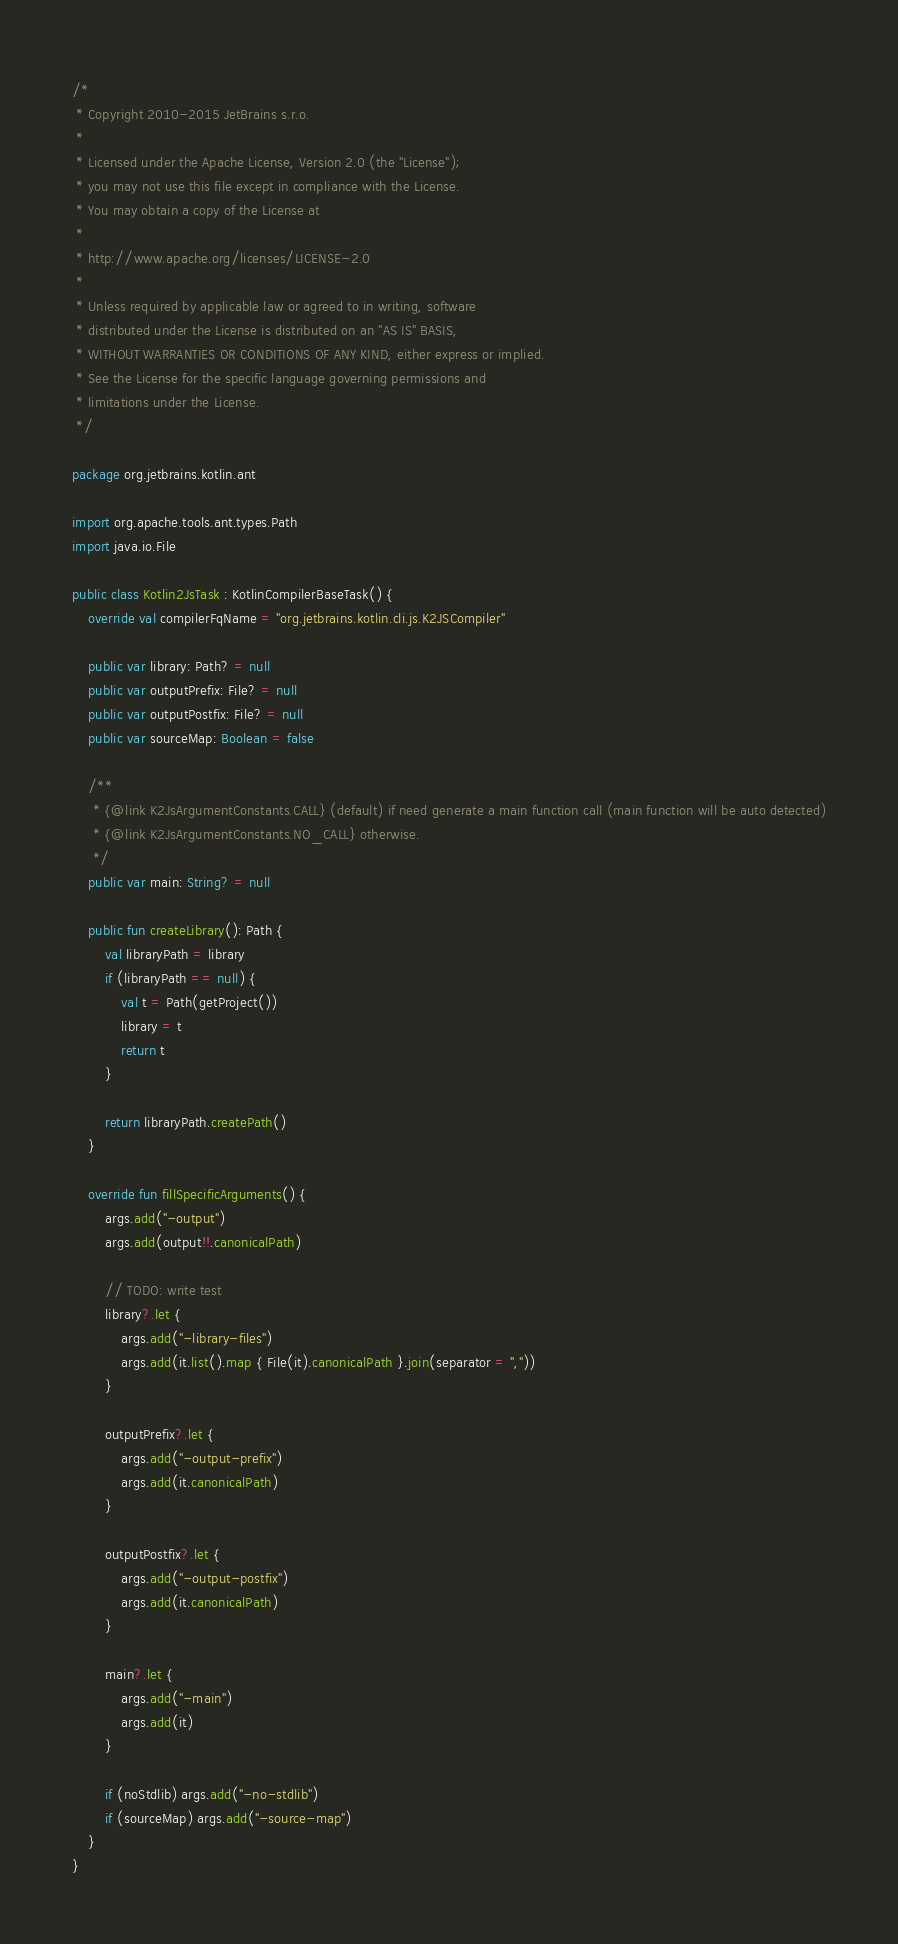Convert code to text. <code><loc_0><loc_0><loc_500><loc_500><_Kotlin_>/*
 * Copyright 2010-2015 JetBrains s.r.o.
 *
 * Licensed under the Apache License, Version 2.0 (the "License");
 * you may not use this file except in compliance with the License.
 * You may obtain a copy of the License at
 *
 * http://www.apache.org/licenses/LICENSE-2.0
 *
 * Unless required by applicable law or agreed to in writing, software
 * distributed under the License is distributed on an "AS IS" BASIS,
 * WITHOUT WARRANTIES OR CONDITIONS OF ANY KIND, either express or implied.
 * See the License for the specific language governing permissions and
 * limitations under the License.
 */

package org.jetbrains.kotlin.ant

import org.apache.tools.ant.types.Path
import java.io.File

public class Kotlin2JsTask : KotlinCompilerBaseTask() {
    override val compilerFqName = "org.jetbrains.kotlin.cli.js.K2JSCompiler"

    public var library: Path? = null
    public var outputPrefix: File? = null
    public var outputPostfix: File? = null
    public var sourceMap: Boolean = false

    /**
     * {@link K2JsArgumentConstants.CALL} (default) if need generate a main function call (main function will be auto detected)
     * {@link K2JsArgumentConstants.NO_CALL} otherwise.
     */
    public var main: String? = null

    public fun createLibrary(): Path {
        val libraryPath = library
        if (libraryPath == null) {
            val t = Path(getProject())
            library = t
            return t
        }

        return libraryPath.createPath()
    }

    override fun fillSpecificArguments() {
        args.add("-output")
        args.add(output!!.canonicalPath)

        // TODO: write test
        library?.let {
            args.add("-library-files")
            args.add(it.list().map { File(it).canonicalPath }.join(separator = ","))
        }

        outputPrefix?.let {
            args.add("-output-prefix")
            args.add(it.canonicalPath)
        }

        outputPostfix?.let {
            args.add("-output-postfix")
            args.add(it.canonicalPath)
        }

        main?.let {
            args.add("-main")
            args.add(it)
        }

        if (noStdlib) args.add("-no-stdlib")
        if (sourceMap) args.add("-source-map")
    }
}
</code> 